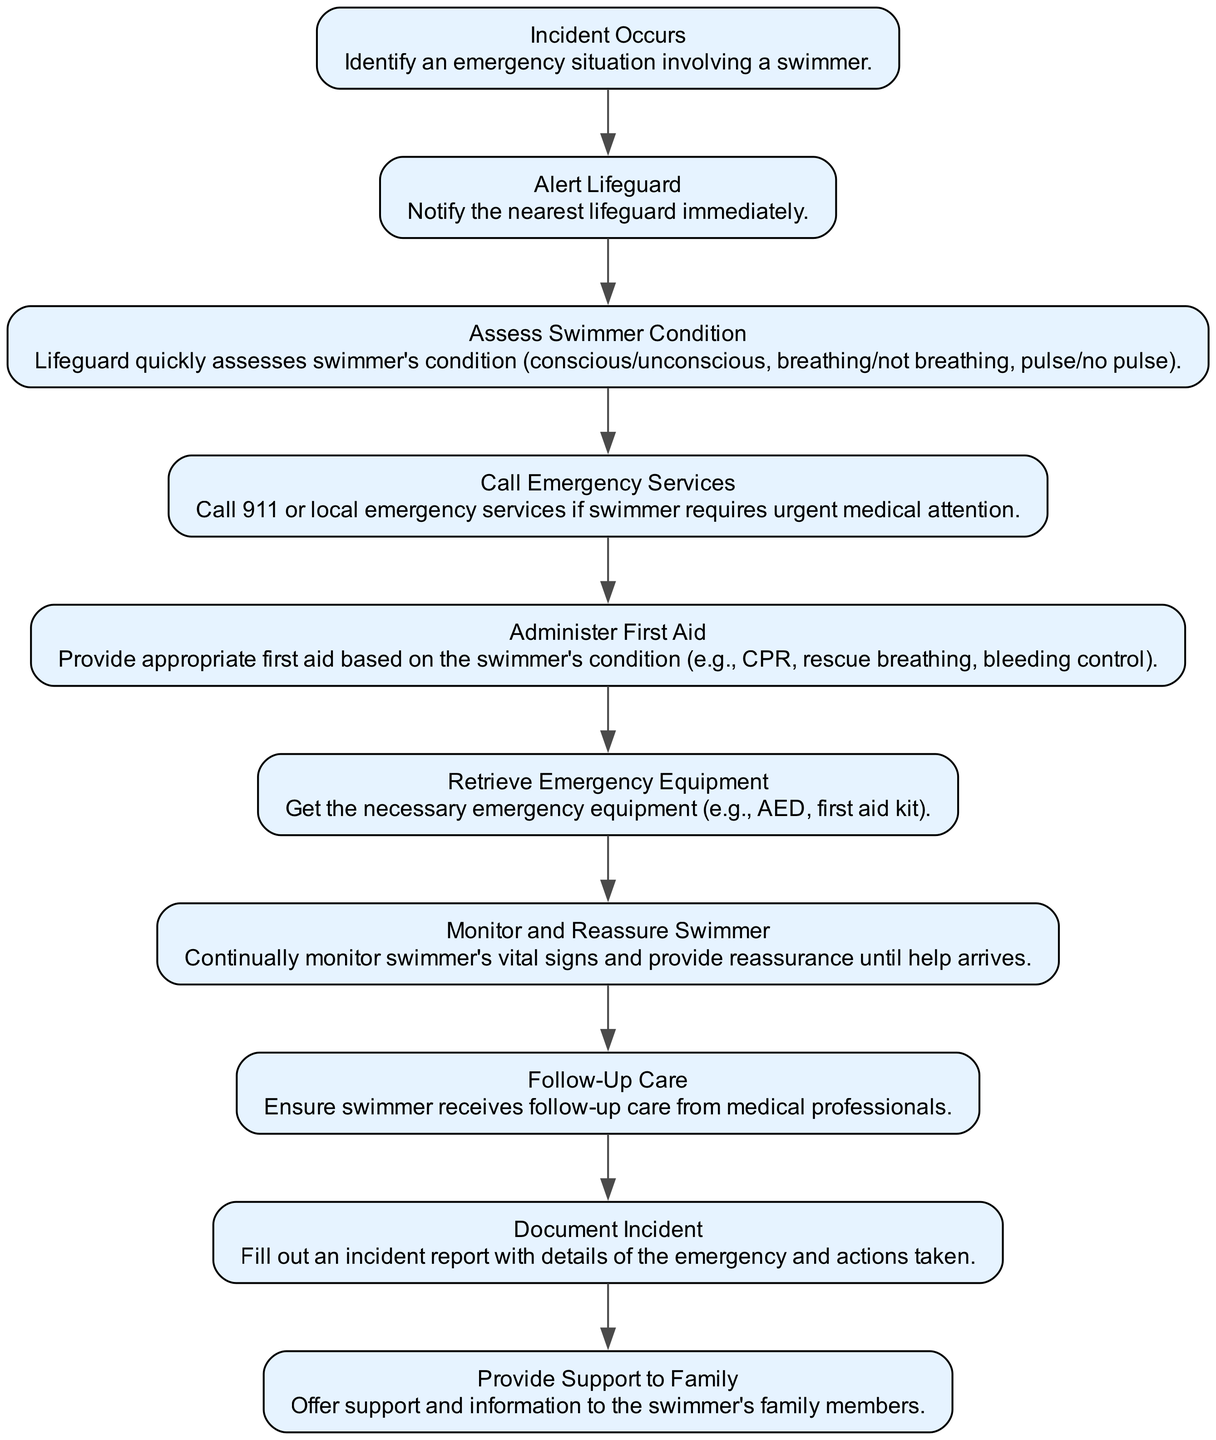What is the first step in the protocol? The first step in the protocol is "Incident Occurs," which identifies an emergency situation involving a swimmer. This is clearly stated as the starting point in the flow chart.
Answer: Incident Occurs How many total nodes are in the diagram? Counting each element listed in the data under "elements," there are a total of 10 nodes. Each element represents a distinct step in the emergency protocol.
Answer: 10 What action should be taken after alerting the lifeguard? After "Alert Lifeguard," the next action according to the flow of the chart is "Assess Swimmer Condition," which is the step immediately following it.
Answer: Assess Swimmer Condition What does "Administer First Aid" involve? "Administer First Aid" involves providing appropriate first aid based on the swimmer's condition, such as CPR, rescue breathing, or bleeding control. This is described specifically under that node in the chart.
Answer: Provide appropriate first aid What is the final step in the protocol? The final step, depending on the flow of information in the diagram, is "Document Incident," which emphasizes the importance of filling out an incident report.
Answer: Document Incident What are the two conditions to assess in the swimmer's condition? The two conditions to assess in the swimmer's condition are "breathing/not breathing" and "pulse/no pulse." This allows for a quick evaluation of the swimmer's status and is detailed in the text under that step.
Answer: Breathing, pulse What happens if the swimmer requires urgent medical attention? If the swimmer requires urgent medical attention, the next action taken is to "Call Emergency Services." This establishes urgency and directs the flow to seek additional help.
Answer: Call Emergency Services Which node comes after "Retrieve Emergency Equipment"? The node that comes after "Retrieve Emergency Equipment" is "Monitor and Reassure Swimmer," indicating that after obtaining the necessary supplies, ongoing support for the swimmer is crucial.
Answer: Monitor and Reassure Swimmer What is the purpose of "Provide Support to Family"? The purpose of "Provide Support to Family" is to offer assistance and information to the swimmer's family members, ensuring that they remain informed during the emergency situation.
Answer: Offer support and information 